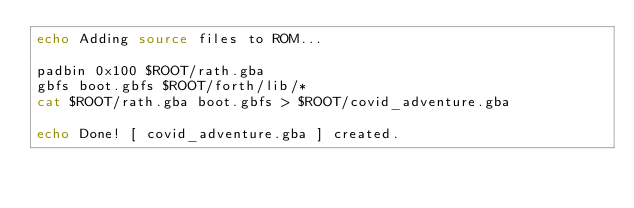Convert code to text. <code><loc_0><loc_0><loc_500><loc_500><_Bash_>echo Adding source files to ROM...

padbin 0x100 $ROOT/rath.gba
gbfs boot.gbfs $ROOT/forth/lib/*
cat $ROOT/rath.gba boot.gbfs > $ROOT/covid_adventure.gba

echo Done! [ covid_adventure.gba ] created.
</code> 